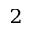Convert formula to latex. <formula><loc_0><loc_0><loc_500><loc_500>^ { 2 }</formula> 